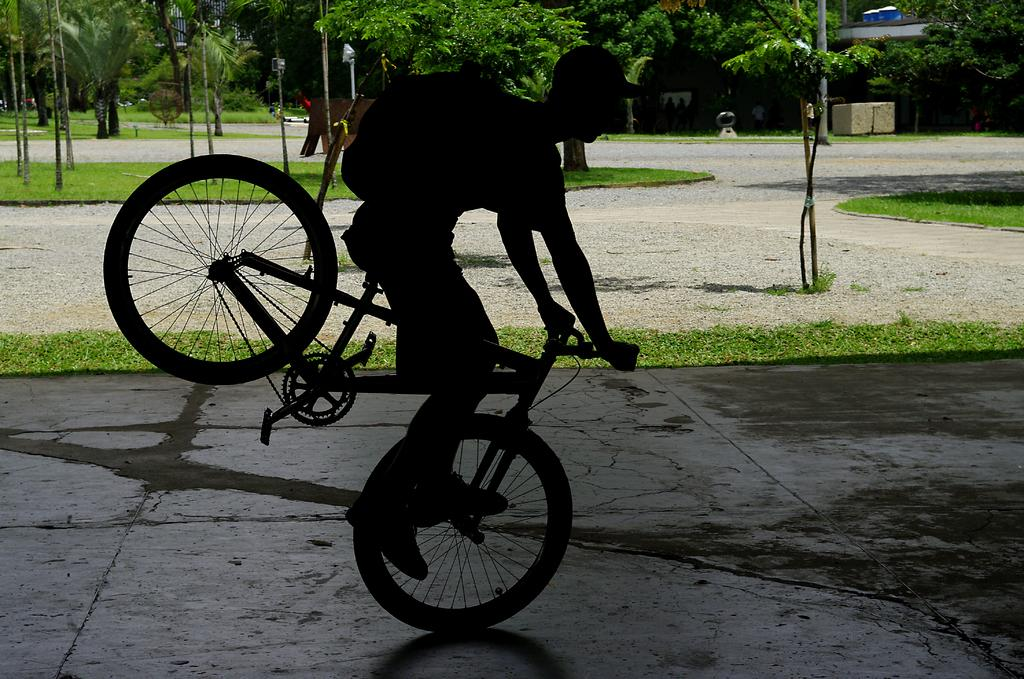What is the person in the image doing? The person is riding a bicycle. What can be seen in the background of the image? There are trees in the background of the image. What type of instrument is the person playing while riding the bicycle in the image? There is no instrument present in the image; the person is only riding a bicycle. How many birds can be seen flying in the image? There are no birds visible in the image; it only features a person riding a bicycle and trees in the background. 